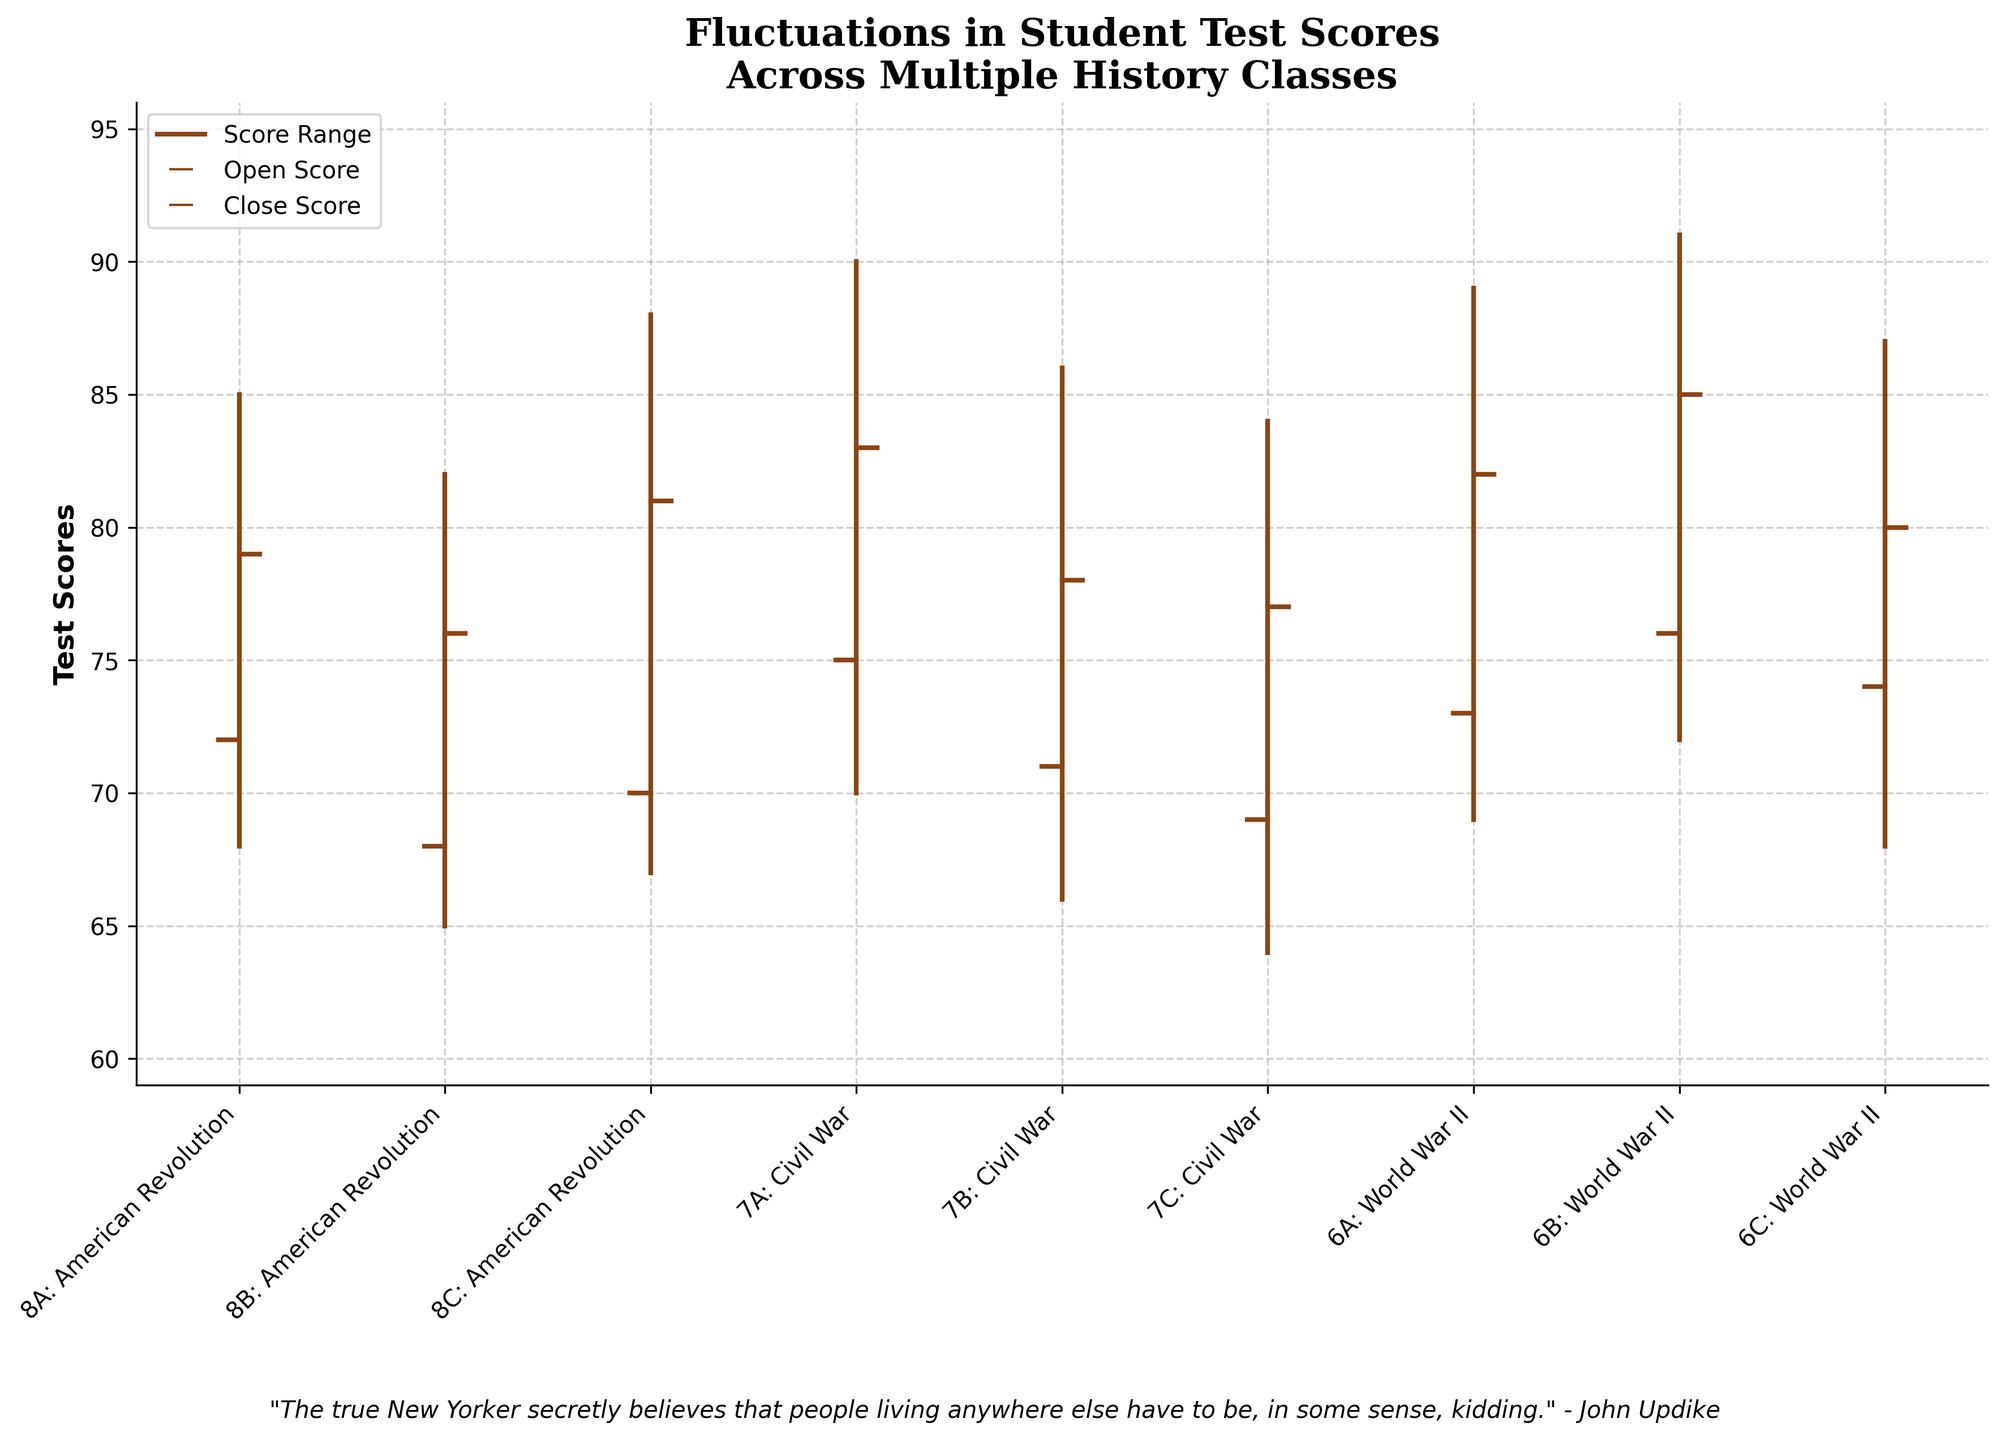What's the title of the chart? The title is located at the top center of the chart. It informs viewers about the subject of the data. The chart's title is "Fluctuations in Student Test Scores Across Multiple History Classes".
Answer: Fluctuations in Student Test Scores Across Multiple History Classes What is the range of test scores displayed in the chart? The range is determined by the lowest and highest values in the data. The lowest score is 64, and the highest score is 91. We calculate the range as the difference between these values.
Answer: 27 Which class had the highest test score during the unit? By looking at the highest scores for each class, we see that the highest score (91) was achieved by class "6B: World War II".
Answer: 6B: World War II What is the median of the closing scores? The closing scores for all classes are: [79, 76, 81, 83, 78, 77, 82, 85, 80]. To find the median, we need to sort these values and find the middle one. The sorted values are: [76, 77, 78, 79, 80, 81, 82, 83, 85], and the median value is the 5th one in the list.
Answer: 80 Which class had the smallest range of scores? The range of scores for each class can be found by subtracting the lowest score from the highest score. For "8A: American Revolution", it's 85-68=17, for "8B: American Revolution", it's 82-65=17, and so on. Among all classes, "8A: American Revolution" and "8B: American Revolution" both have the smallest range, which is 17.
Answer: 8A: American Revolution, 8B: American Revolution How many American Revolution classes are there in total? The classes related to the American Revolution are "8A: American Revolution", "8B: American Revolution", and "8C: American Revolution". By counting these, we find there are 3 American Revolution classes.
Answer: 3 Which class showed the greatest improvement from the opening to the closing score? Improvement is calculated as the difference between the closing and opening scores. For each class: "8A: American Revolution" improved by 79-72=7, "8B: American Revolution" by 76-68=8, etc. The greatest improvement of 9 points is seen in "6A: World War II".
Answer: 6A: World War II What is the average opening score for all class groups combined? The opening scores are: [72, 68, 70, 75, 71, 69, 73, 76, 74]. We add them up to get 648, then divide by the total number of classes (9).
Answer: 72 Which class had the lowest closing score? By looking at the closing scores, we identify that "8B: American Revolution" had the lowest closing score, which is 76.
Answer: 8B: American Revolution What is the overall trend shown in the chart: are scores improving, declining, or stable overall? To determine the trend, we look at the opening and closing scores across all classes. It appears that most classes close higher than they open, indicating an overall improvement trend.
Answer: Improving 